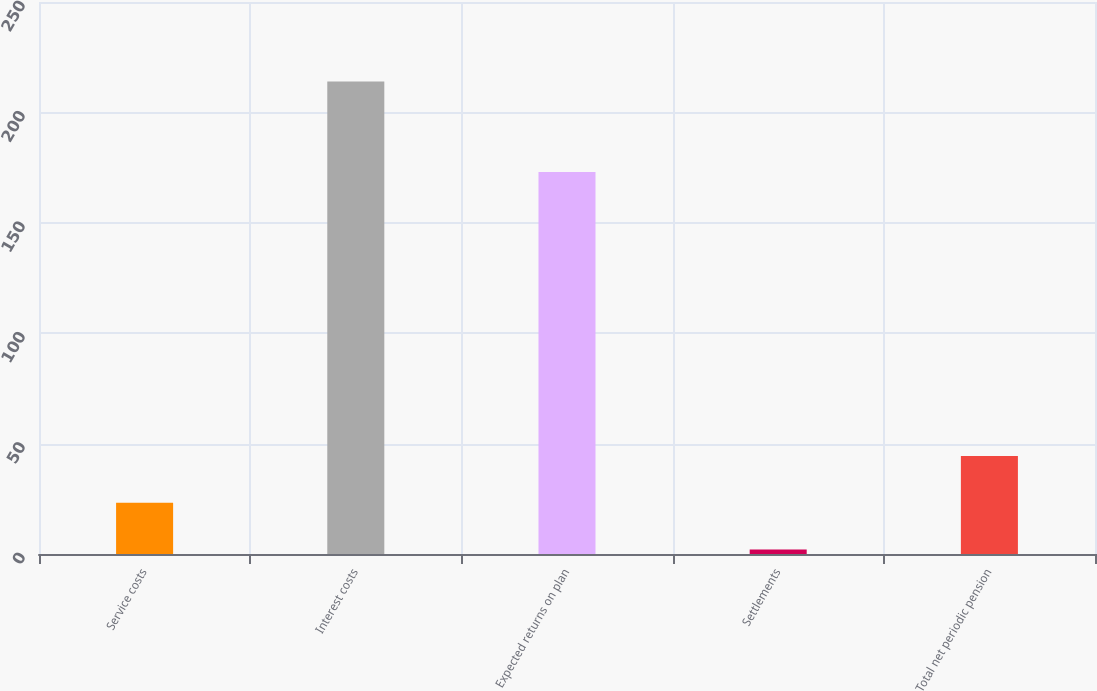Convert chart. <chart><loc_0><loc_0><loc_500><loc_500><bar_chart><fcel>Service costs<fcel>Interest costs<fcel>Expected returns on plan<fcel>Settlements<fcel>Total net periodic pension<nl><fcel>23.2<fcel>214<fcel>173<fcel>2<fcel>44.4<nl></chart> 